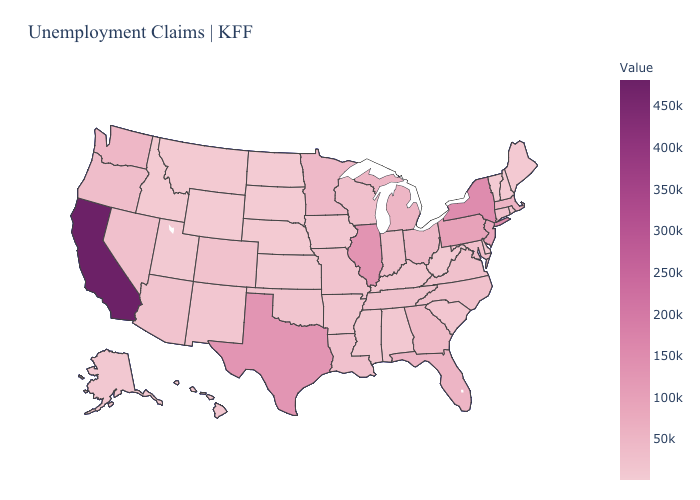Which states have the lowest value in the Northeast?
Give a very brief answer. Vermont. Among the states that border New York , which have the lowest value?
Keep it brief. Vermont. Which states have the lowest value in the West?
Short answer required. Wyoming. Among the states that border Idaho , which have the highest value?
Keep it brief. Washington. Among the states that border Wyoming , does South Dakota have the lowest value?
Give a very brief answer. Yes. Does Colorado have the highest value in the USA?
Short answer required. No. 